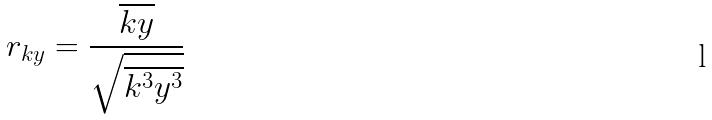<formula> <loc_0><loc_0><loc_500><loc_500>r _ { k y } = \frac { \overline { k y } } { \sqrt { \overline { k ^ { 3 } } \overline { y ^ { 3 } } } }</formula> 